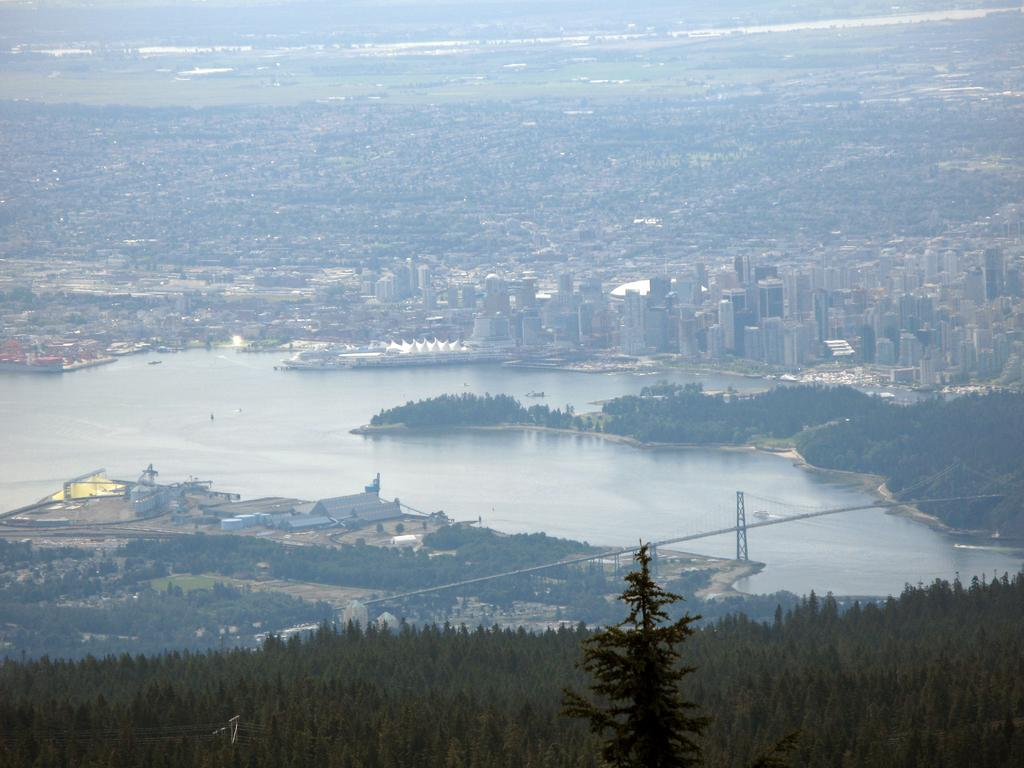What is located in the middle of the image? There is water in the middle of the image. What type of vegetation can be seen at the bottom of the image? There are trees at the bottom of the image. What type of structures are visible at the back side of the image? There are big buildings at the back side of the image. Where is the locket hidden in the image? There is no locket present in the image. What type of ball can be seen bouncing in the water? There is no ball present in the image. 